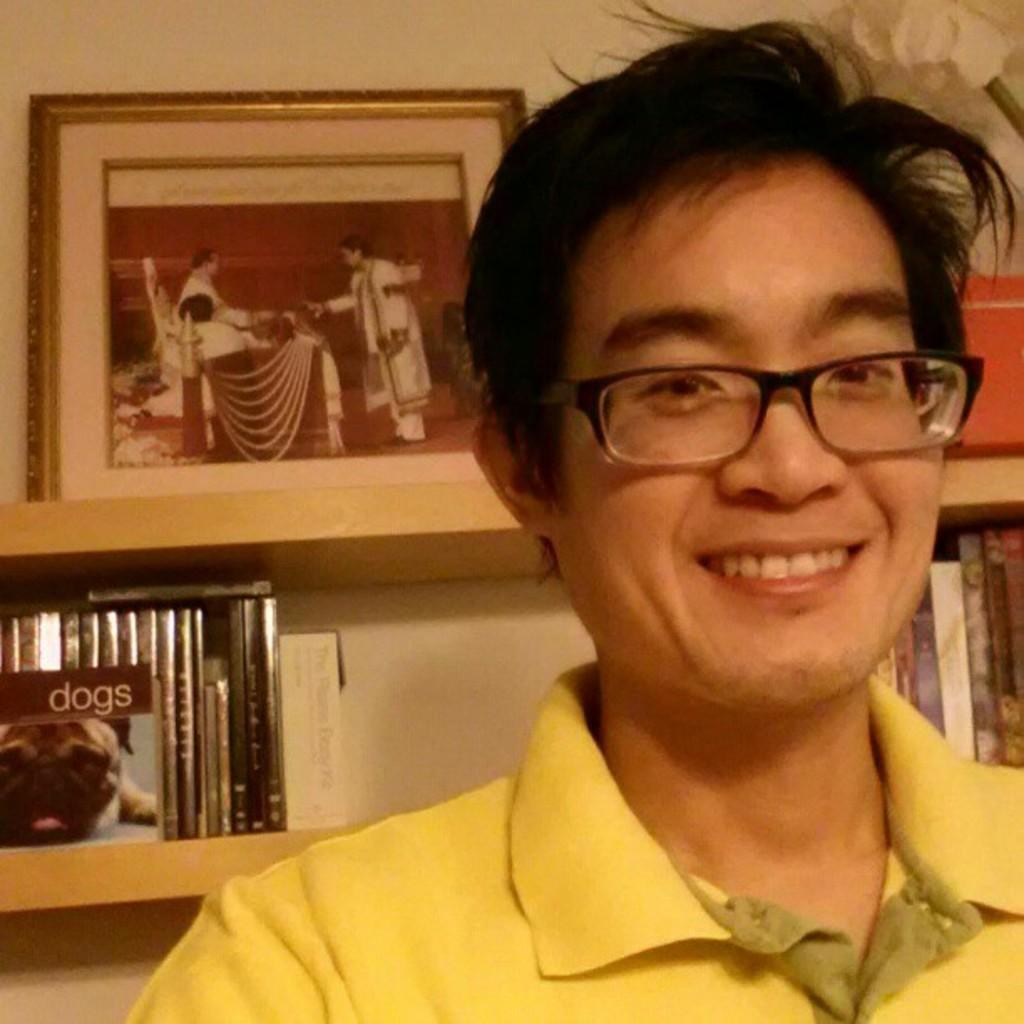Could you give a brief overview of what you see in this image? In the background we can see a frame, books and objects arranged in the racks. In this picture we can see a man wearing spectacles and yellow t-shirt. He is smiling. 